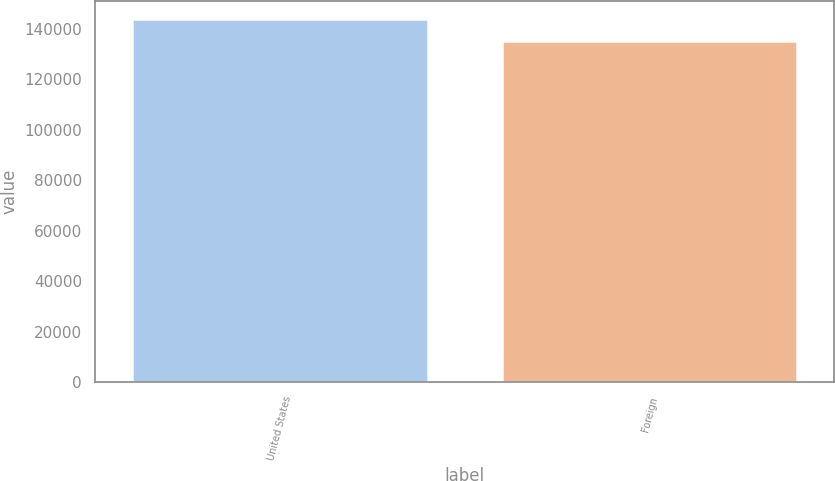Convert chart. <chart><loc_0><loc_0><loc_500><loc_500><bar_chart><fcel>United States<fcel>Foreign<nl><fcel>143924<fcel>135141<nl></chart> 